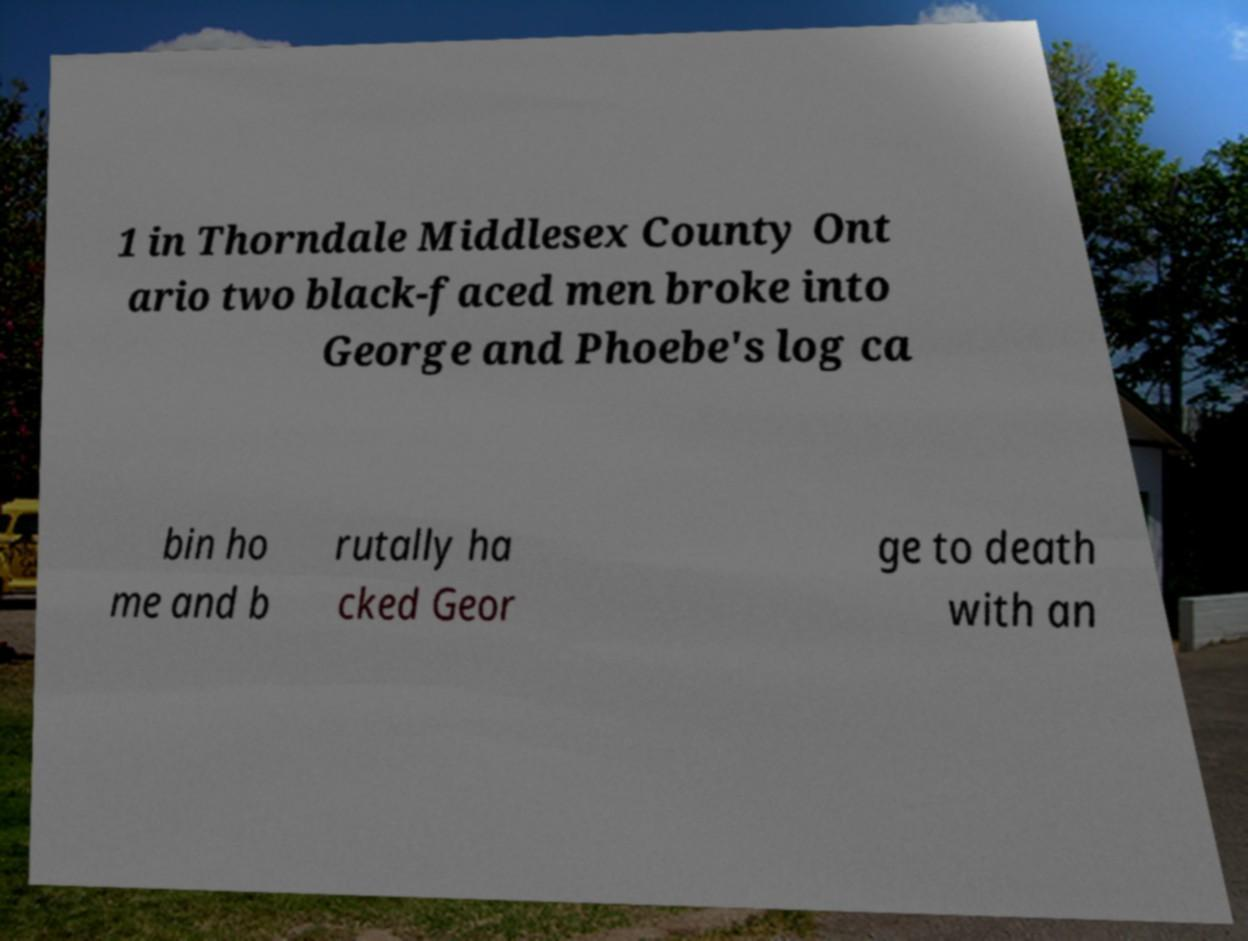Could you extract and type out the text from this image? 1 in Thorndale Middlesex County Ont ario two black-faced men broke into George and Phoebe's log ca bin ho me and b rutally ha cked Geor ge to death with an 